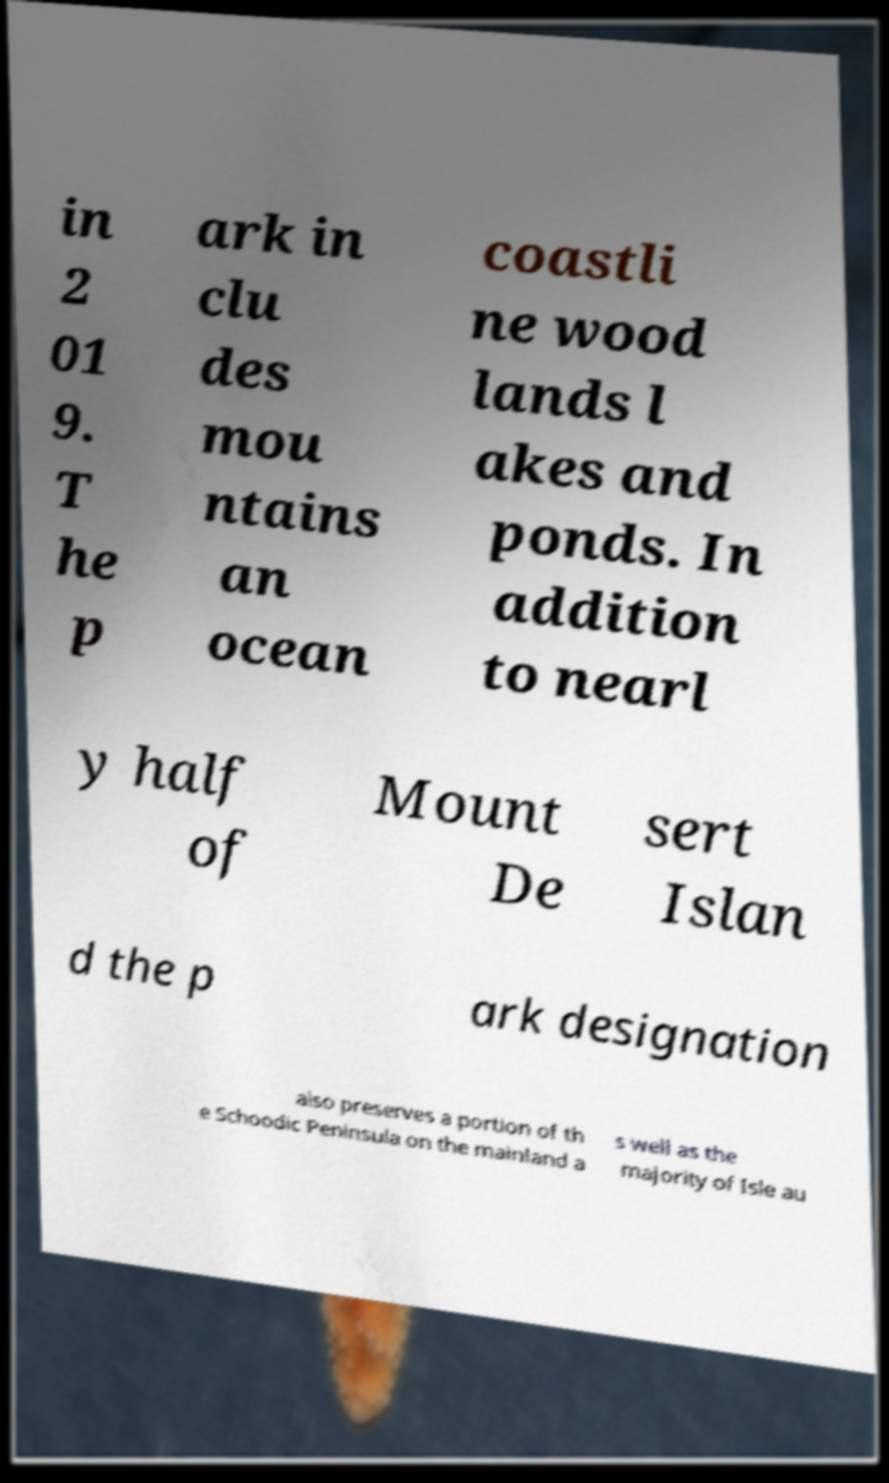Could you extract and type out the text from this image? in 2 01 9. T he p ark in clu des mou ntains an ocean coastli ne wood lands l akes and ponds. In addition to nearl y half of Mount De sert Islan d the p ark designation also preserves a portion of th e Schoodic Peninsula on the mainland a s well as the majority of Isle au 